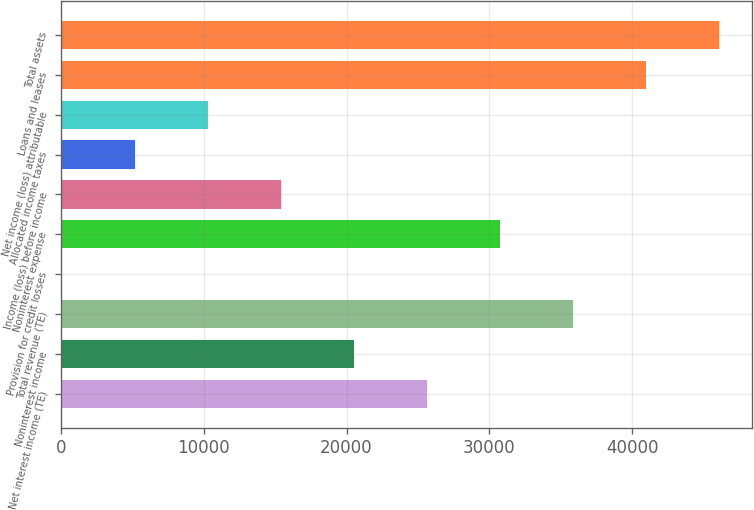Convert chart to OTSL. <chart><loc_0><loc_0><loc_500><loc_500><bar_chart><fcel>Net interest income (TE)<fcel>Noninterest income<fcel>Total revenue (TE)<fcel>Provision for credit losses<fcel>Noninterest expense<fcel>Income (loss) before income<fcel>Allocated income taxes<fcel>Net income (loss) attributable<fcel>Loans and leases<fcel>Total assets<nl><fcel>25617<fcel>20507.6<fcel>35835.8<fcel>70<fcel>30726.4<fcel>15398.2<fcel>5179.4<fcel>10288.8<fcel>40945.2<fcel>46054.6<nl></chart> 